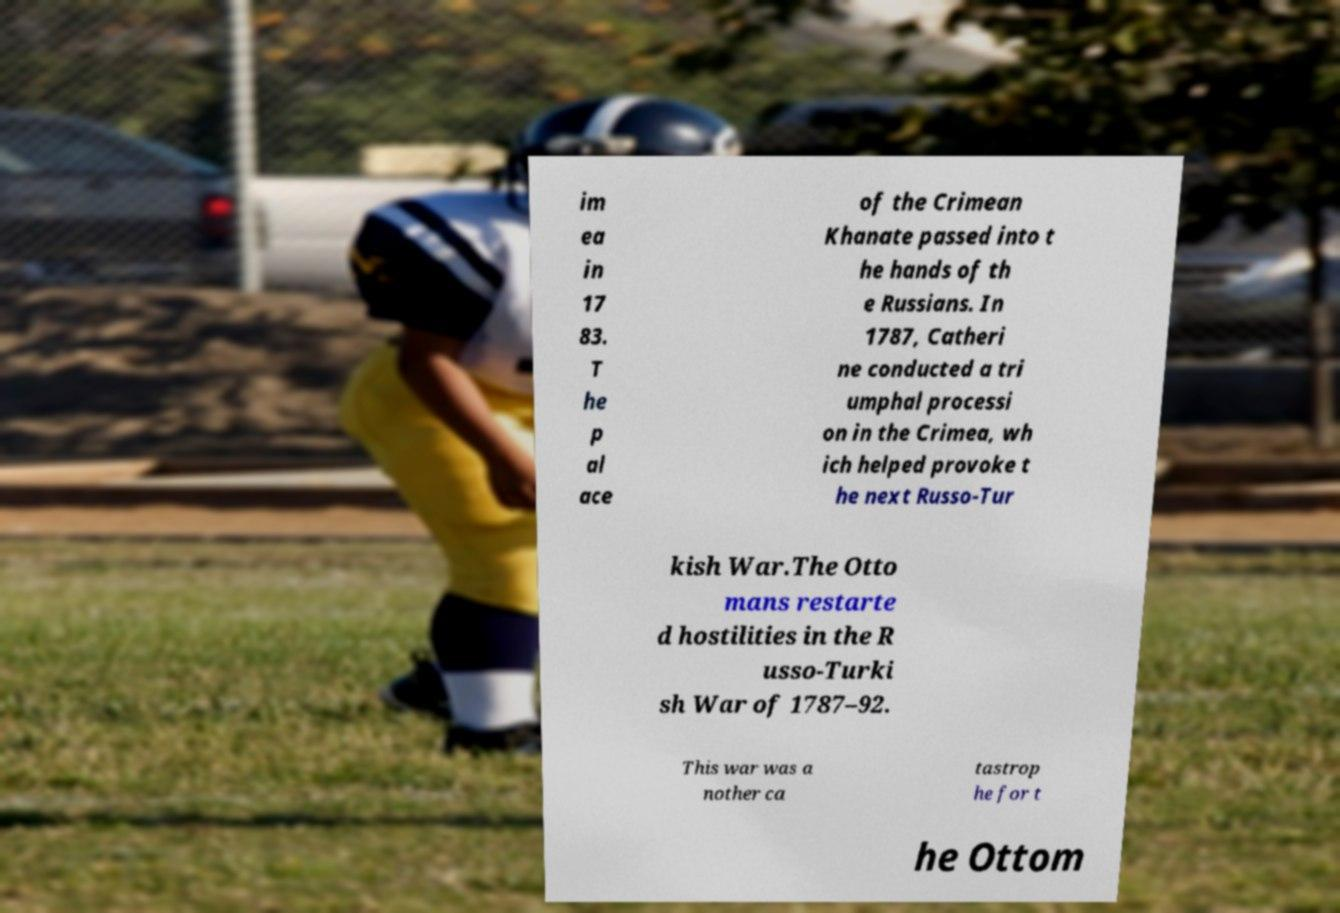Please read and relay the text visible in this image. What does it say? im ea in 17 83. T he p al ace of the Crimean Khanate passed into t he hands of th e Russians. In 1787, Catheri ne conducted a tri umphal processi on in the Crimea, wh ich helped provoke t he next Russo-Tur kish War.The Otto mans restarte d hostilities in the R usso-Turki sh War of 1787–92. This war was a nother ca tastrop he for t he Ottom 